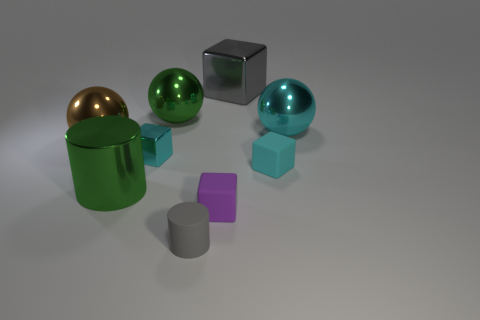How many things are rubber cylinders or cyan metal blocks?
Provide a short and direct response. 2. What color is the big block that is the same material as the large cylinder?
Your answer should be very brief. Gray. There is a big metallic thing that is in front of the tiny cyan matte thing; does it have the same shape as the big brown object?
Offer a very short reply. No. How many things are big objects behind the brown metallic thing or big metallic things left of the small metal cube?
Ensure brevity in your answer.  5. There is another large object that is the same shape as the cyan rubber thing; what color is it?
Your answer should be compact. Gray. There is a purple thing; does it have the same shape as the gray thing behind the big brown ball?
Provide a short and direct response. Yes. What is the large gray object made of?
Provide a succinct answer. Metal. The green metallic thing that is the same shape as the big cyan object is what size?
Ensure brevity in your answer.  Large. What number of other objects are there of the same material as the green cylinder?
Offer a very short reply. 5. Is the material of the gray cylinder the same as the big green thing in front of the big brown thing?
Your answer should be compact. No. 